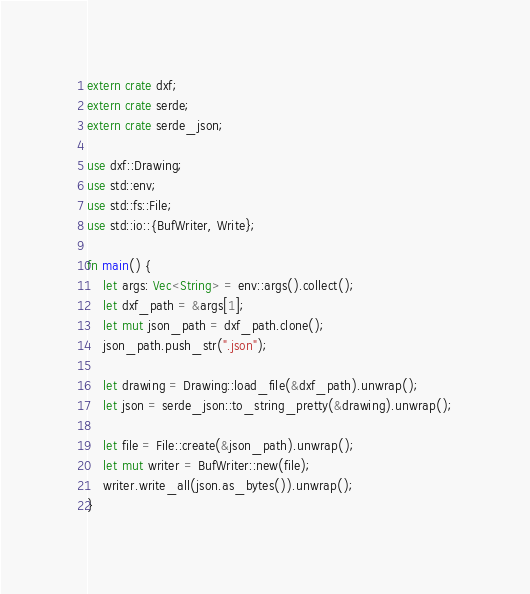<code> <loc_0><loc_0><loc_500><loc_500><_Rust_>extern crate dxf;
extern crate serde;
extern crate serde_json;

use dxf::Drawing;
use std::env;
use std::fs::File;
use std::io::{BufWriter, Write};

fn main() {
    let args: Vec<String> = env::args().collect();
    let dxf_path = &args[1];
    let mut json_path = dxf_path.clone();
    json_path.push_str(".json");

    let drawing = Drawing::load_file(&dxf_path).unwrap();
    let json = serde_json::to_string_pretty(&drawing).unwrap();

    let file = File::create(&json_path).unwrap();
    let mut writer = BufWriter::new(file);
    writer.write_all(json.as_bytes()).unwrap();
}
</code> 